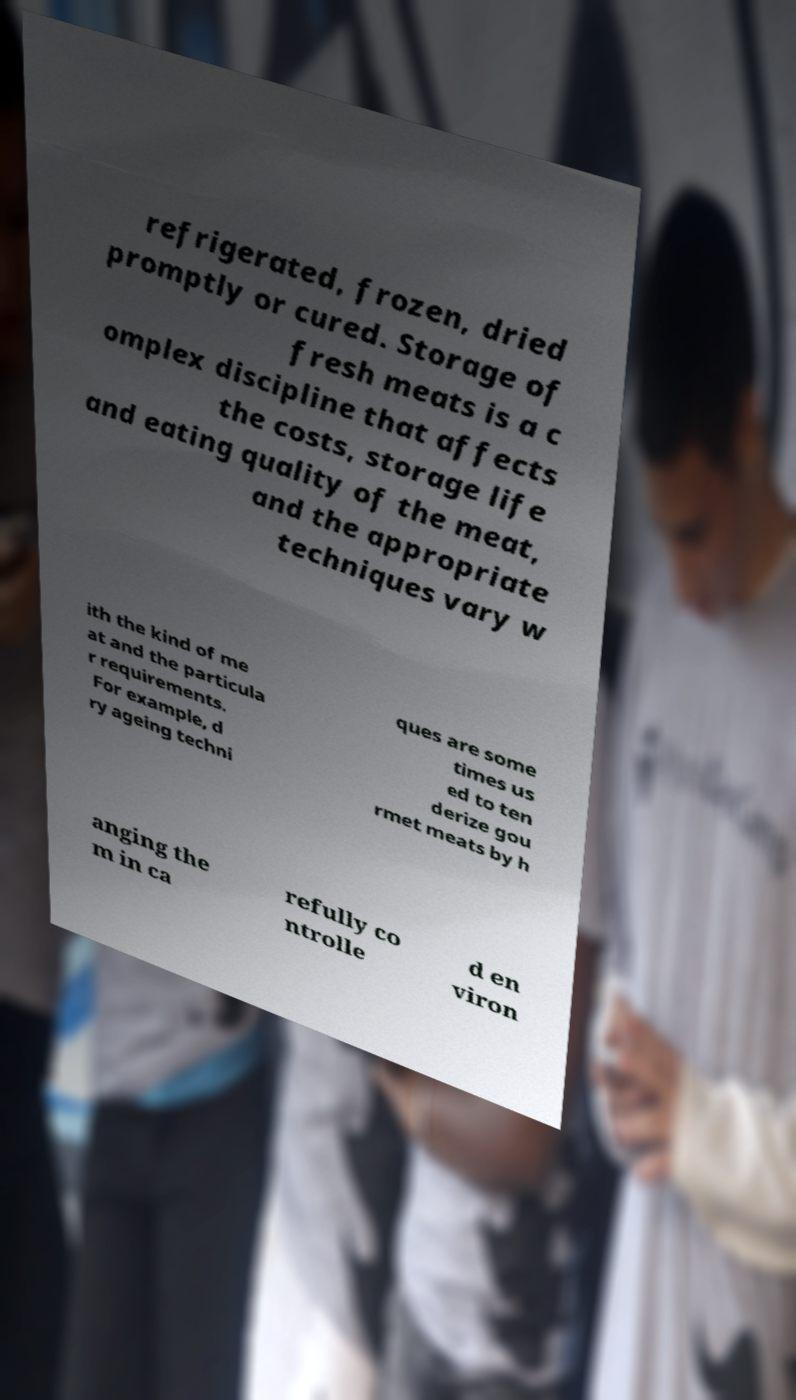Could you extract and type out the text from this image? refrigerated, frozen, dried promptly or cured. Storage of fresh meats is a c omplex discipline that affects the costs, storage life and eating quality of the meat, and the appropriate techniques vary w ith the kind of me at and the particula r requirements. For example, d ry ageing techni ques are some times us ed to ten derize gou rmet meats by h anging the m in ca refully co ntrolle d en viron 